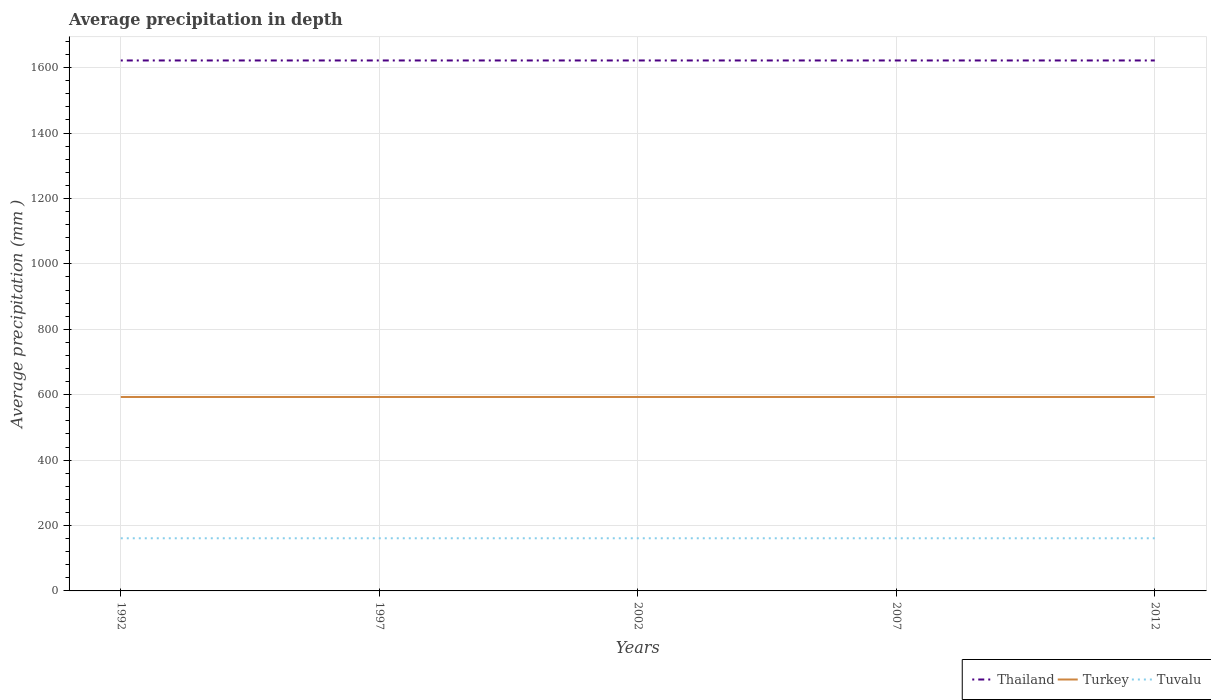Across all years, what is the maximum average precipitation in Tuvalu?
Provide a short and direct response. 161. What is the total average precipitation in Tuvalu in the graph?
Your response must be concise. 0. What is the difference between the highest and the second highest average precipitation in Thailand?
Give a very brief answer. 0. Is the average precipitation in Thailand strictly greater than the average precipitation in Turkey over the years?
Your response must be concise. No. How many lines are there?
Ensure brevity in your answer.  3. How many years are there in the graph?
Offer a terse response. 5. What is the difference between two consecutive major ticks on the Y-axis?
Provide a succinct answer. 200. How many legend labels are there?
Offer a very short reply. 3. How are the legend labels stacked?
Your response must be concise. Horizontal. What is the title of the graph?
Ensure brevity in your answer.  Average precipitation in depth. What is the label or title of the Y-axis?
Your answer should be compact. Average precipitation (mm ). What is the Average precipitation (mm ) of Thailand in 1992?
Your answer should be very brief. 1622. What is the Average precipitation (mm ) of Turkey in 1992?
Keep it short and to the point. 593. What is the Average precipitation (mm ) of Tuvalu in 1992?
Give a very brief answer. 161. What is the Average precipitation (mm ) of Thailand in 1997?
Your answer should be compact. 1622. What is the Average precipitation (mm ) of Turkey in 1997?
Make the answer very short. 593. What is the Average precipitation (mm ) of Tuvalu in 1997?
Make the answer very short. 161. What is the Average precipitation (mm ) of Thailand in 2002?
Give a very brief answer. 1622. What is the Average precipitation (mm ) in Turkey in 2002?
Offer a terse response. 593. What is the Average precipitation (mm ) in Tuvalu in 2002?
Ensure brevity in your answer.  161. What is the Average precipitation (mm ) of Thailand in 2007?
Keep it short and to the point. 1622. What is the Average precipitation (mm ) in Turkey in 2007?
Ensure brevity in your answer.  593. What is the Average precipitation (mm ) in Tuvalu in 2007?
Make the answer very short. 161. What is the Average precipitation (mm ) in Thailand in 2012?
Offer a very short reply. 1622. What is the Average precipitation (mm ) in Turkey in 2012?
Provide a succinct answer. 593. What is the Average precipitation (mm ) of Tuvalu in 2012?
Ensure brevity in your answer.  161. Across all years, what is the maximum Average precipitation (mm ) in Thailand?
Your response must be concise. 1622. Across all years, what is the maximum Average precipitation (mm ) in Turkey?
Your answer should be compact. 593. Across all years, what is the maximum Average precipitation (mm ) of Tuvalu?
Your response must be concise. 161. Across all years, what is the minimum Average precipitation (mm ) in Thailand?
Ensure brevity in your answer.  1622. Across all years, what is the minimum Average precipitation (mm ) of Turkey?
Your answer should be very brief. 593. Across all years, what is the minimum Average precipitation (mm ) in Tuvalu?
Offer a terse response. 161. What is the total Average precipitation (mm ) in Thailand in the graph?
Your answer should be very brief. 8110. What is the total Average precipitation (mm ) in Turkey in the graph?
Your answer should be very brief. 2965. What is the total Average precipitation (mm ) in Tuvalu in the graph?
Your answer should be very brief. 805. What is the difference between the Average precipitation (mm ) in Turkey in 1992 and that in 1997?
Your response must be concise. 0. What is the difference between the Average precipitation (mm ) of Thailand in 1992 and that in 2002?
Provide a succinct answer. 0. What is the difference between the Average precipitation (mm ) in Tuvalu in 1992 and that in 2002?
Your response must be concise. 0. What is the difference between the Average precipitation (mm ) of Turkey in 1992 and that in 2007?
Ensure brevity in your answer.  0. What is the difference between the Average precipitation (mm ) in Tuvalu in 1992 and that in 2007?
Keep it short and to the point. 0. What is the difference between the Average precipitation (mm ) of Turkey in 1992 and that in 2012?
Provide a short and direct response. 0. What is the difference between the Average precipitation (mm ) of Tuvalu in 1992 and that in 2012?
Provide a succinct answer. 0. What is the difference between the Average precipitation (mm ) in Tuvalu in 1997 and that in 2002?
Provide a succinct answer. 0. What is the difference between the Average precipitation (mm ) of Turkey in 1997 and that in 2007?
Keep it short and to the point. 0. What is the difference between the Average precipitation (mm ) in Turkey in 1997 and that in 2012?
Give a very brief answer. 0. What is the difference between the Average precipitation (mm ) of Tuvalu in 1997 and that in 2012?
Make the answer very short. 0. What is the difference between the Average precipitation (mm ) of Thailand in 2002 and that in 2007?
Provide a succinct answer. 0. What is the difference between the Average precipitation (mm ) in Turkey in 2002 and that in 2007?
Your answer should be compact. 0. What is the difference between the Average precipitation (mm ) of Tuvalu in 2002 and that in 2012?
Keep it short and to the point. 0. What is the difference between the Average precipitation (mm ) in Thailand in 1992 and the Average precipitation (mm ) in Turkey in 1997?
Your answer should be compact. 1029. What is the difference between the Average precipitation (mm ) in Thailand in 1992 and the Average precipitation (mm ) in Tuvalu in 1997?
Ensure brevity in your answer.  1461. What is the difference between the Average precipitation (mm ) of Turkey in 1992 and the Average precipitation (mm ) of Tuvalu in 1997?
Provide a succinct answer. 432. What is the difference between the Average precipitation (mm ) in Thailand in 1992 and the Average precipitation (mm ) in Turkey in 2002?
Offer a terse response. 1029. What is the difference between the Average precipitation (mm ) in Thailand in 1992 and the Average precipitation (mm ) in Tuvalu in 2002?
Ensure brevity in your answer.  1461. What is the difference between the Average precipitation (mm ) in Turkey in 1992 and the Average precipitation (mm ) in Tuvalu in 2002?
Keep it short and to the point. 432. What is the difference between the Average precipitation (mm ) in Thailand in 1992 and the Average precipitation (mm ) in Turkey in 2007?
Your answer should be very brief. 1029. What is the difference between the Average precipitation (mm ) of Thailand in 1992 and the Average precipitation (mm ) of Tuvalu in 2007?
Your answer should be very brief. 1461. What is the difference between the Average precipitation (mm ) of Turkey in 1992 and the Average precipitation (mm ) of Tuvalu in 2007?
Offer a very short reply. 432. What is the difference between the Average precipitation (mm ) of Thailand in 1992 and the Average precipitation (mm ) of Turkey in 2012?
Provide a short and direct response. 1029. What is the difference between the Average precipitation (mm ) in Thailand in 1992 and the Average precipitation (mm ) in Tuvalu in 2012?
Your answer should be very brief. 1461. What is the difference between the Average precipitation (mm ) in Turkey in 1992 and the Average precipitation (mm ) in Tuvalu in 2012?
Your answer should be compact. 432. What is the difference between the Average precipitation (mm ) of Thailand in 1997 and the Average precipitation (mm ) of Turkey in 2002?
Ensure brevity in your answer.  1029. What is the difference between the Average precipitation (mm ) in Thailand in 1997 and the Average precipitation (mm ) in Tuvalu in 2002?
Your answer should be compact. 1461. What is the difference between the Average precipitation (mm ) in Turkey in 1997 and the Average precipitation (mm ) in Tuvalu in 2002?
Provide a short and direct response. 432. What is the difference between the Average precipitation (mm ) in Thailand in 1997 and the Average precipitation (mm ) in Turkey in 2007?
Keep it short and to the point. 1029. What is the difference between the Average precipitation (mm ) of Thailand in 1997 and the Average precipitation (mm ) of Tuvalu in 2007?
Give a very brief answer. 1461. What is the difference between the Average precipitation (mm ) in Turkey in 1997 and the Average precipitation (mm ) in Tuvalu in 2007?
Give a very brief answer. 432. What is the difference between the Average precipitation (mm ) in Thailand in 1997 and the Average precipitation (mm ) in Turkey in 2012?
Your answer should be compact. 1029. What is the difference between the Average precipitation (mm ) of Thailand in 1997 and the Average precipitation (mm ) of Tuvalu in 2012?
Offer a very short reply. 1461. What is the difference between the Average precipitation (mm ) in Turkey in 1997 and the Average precipitation (mm ) in Tuvalu in 2012?
Your response must be concise. 432. What is the difference between the Average precipitation (mm ) in Thailand in 2002 and the Average precipitation (mm ) in Turkey in 2007?
Keep it short and to the point. 1029. What is the difference between the Average precipitation (mm ) of Thailand in 2002 and the Average precipitation (mm ) of Tuvalu in 2007?
Your answer should be compact. 1461. What is the difference between the Average precipitation (mm ) in Turkey in 2002 and the Average precipitation (mm ) in Tuvalu in 2007?
Make the answer very short. 432. What is the difference between the Average precipitation (mm ) of Thailand in 2002 and the Average precipitation (mm ) of Turkey in 2012?
Provide a succinct answer. 1029. What is the difference between the Average precipitation (mm ) in Thailand in 2002 and the Average precipitation (mm ) in Tuvalu in 2012?
Your response must be concise. 1461. What is the difference between the Average precipitation (mm ) of Turkey in 2002 and the Average precipitation (mm ) of Tuvalu in 2012?
Your answer should be very brief. 432. What is the difference between the Average precipitation (mm ) of Thailand in 2007 and the Average precipitation (mm ) of Turkey in 2012?
Keep it short and to the point. 1029. What is the difference between the Average precipitation (mm ) in Thailand in 2007 and the Average precipitation (mm ) in Tuvalu in 2012?
Make the answer very short. 1461. What is the difference between the Average precipitation (mm ) of Turkey in 2007 and the Average precipitation (mm ) of Tuvalu in 2012?
Provide a succinct answer. 432. What is the average Average precipitation (mm ) in Thailand per year?
Make the answer very short. 1622. What is the average Average precipitation (mm ) in Turkey per year?
Keep it short and to the point. 593. What is the average Average precipitation (mm ) of Tuvalu per year?
Provide a short and direct response. 161. In the year 1992, what is the difference between the Average precipitation (mm ) of Thailand and Average precipitation (mm ) of Turkey?
Make the answer very short. 1029. In the year 1992, what is the difference between the Average precipitation (mm ) of Thailand and Average precipitation (mm ) of Tuvalu?
Make the answer very short. 1461. In the year 1992, what is the difference between the Average precipitation (mm ) in Turkey and Average precipitation (mm ) in Tuvalu?
Ensure brevity in your answer.  432. In the year 1997, what is the difference between the Average precipitation (mm ) in Thailand and Average precipitation (mm ) in Turkey?
Your answer should be very brief. 1029. In the year 1997, what is the difference between the Average precipitation (mm ) of Thailand and Average precipitation (mm ) of Tuvalu?
Your answer should be compact. 1461. In the year 1997, what is the difference between the Average precipitation (mm ) of Turkey and Average precipitation (mm ) of Tuvalu?
Your response must be concise. 432. In the year 2002, what is the difference between the Average precipitation (mm ) in Thailand and Average precipitation (mm ) in Turkey?
Keep it short and to the point. 1029. In the year 2002, what is the difference between the Average precipitation (mm ) in Thailand and Average precipitation (mm ) in Tuvalu?
Keep it short and to the point. 1461. In the year 2002, what is the difference between the Average precipitation (mm ) in Turkey and Average precipitation (mm ) in Tuvalu?
Give a very brief answer. 432. In the year 2007, what is the difference between the Average precipitation (mm ) of Thailand and Average precipitation (mm ) of Turkey?
Give a very brief answer. 1029. In the year 2007, what is the difference between the Average precipitation (mm ) of Thailand and Average precipitation (mm ) of Tuvalu?
Keep it short and to the point. 1461. In the year 2007, what is the difference between the Average precipitation (mm ) in Turkey and Average precipitation (mm ) in Tuvalu?
Offer a very short reply. 432. In the year 2012, what is the difference between the Average precipitation (mm ) in Thailand and Average precipitation (mm ) in Turkey?
Your answer should be very brief. 1029. In the year 2012, what is the difference between the Average precipitation (mm ) of Thailand and Average precipitation (mm ) of Tuvalu?
Make the answer very short. 1461. In the year 2012, what is the difference between the Average precipitation (mm ) of Turkey and Average precipitation (mm ) of Tuvalu?
Your response must be concise. 432. What is the ratio of the Average precipitation (mm ) in Tuvalu in 1992 to that in 1997?
Offer a very short reply. 1. What is the ratio of the Average precipitation (mm ) of Turkey in 1992 to that in 2007?
Your answer should be very brief. 1. What is the ratio of the Average precipitation (mm ) in Tuvalu in 1992 to that in 2007?
Your answer should be very brief. 1. What is the ratio of the Average precipitation (mm ) in Thailand in 1992 to that in 2012?
Offer a very short reply. 1. What is the ratio of the Average precipitation (mm ) in Tuvalu in 1992 to that in 2012?
Your answer should be compact. 1. What is the ratio of the Average precipitation (mm ) of Turkey in 1997 to that in 2002?
Your answer should be very brief. 1. What is the ratio of the Average precipitation (mm ) in Thailand in 1997 to that in 2007?
Give a very brief answer. 1. What is the ratio of the Average precipitation (mm ) of Turkey in 1997 to that in 2007?
Offer a very short reply. 1. What is the ratio of the Average precipitation (mm ) in Tuvalu in 2002 to that in 2007?
Your answer should be very brief. 1. What is the ratio of the Average precipitation (mm ) of Thailand in 2002 to that in 2012?
Ensure brevity in your answer.  1. What is the ratio of the Average precipitation (mm ) in Turkey in 2002 to that in 2012?
Your answer should be very brief. 1. What is the ratio of the Average precipitation (mm ) in Thailand in 2007 to that in 2012?
Provide a succinct answer. 1. What is the ratio of the Average precipitation (mm ) of Turkey in 2007 to that in 2012?
Ensure brevity in your answer.  1. What is the difference between the highest and the lowest Average precipitation (mm ) in Thailand?
Provide a short and direct response. 0. What is the difference between the highest and the lowest Average precipitation (mm ) of Turkey?
Make the answer very short. 0. 